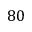Convert formula to latex. <formula><loc_0><loc_0><loc_500><loc_500>8 0</formula> 